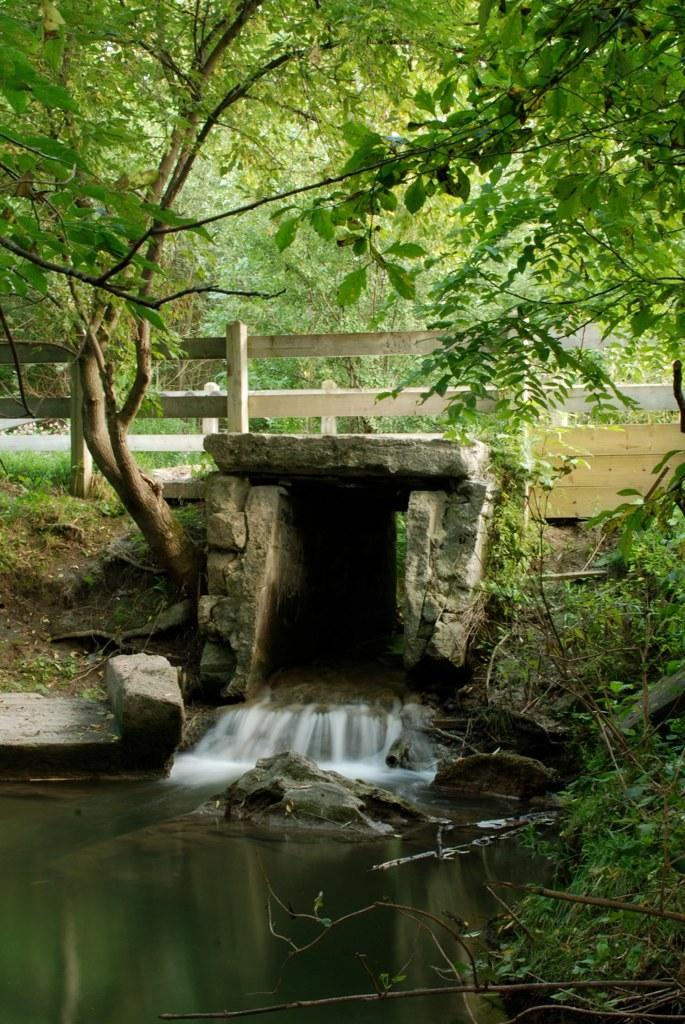What body of water is present at the bottom of the image? There is a lake at the bottom of the image. What structure can be seen crossing the lake? There is a bridge in the center of the image. What type of vegetation is visible in the image? There are plants and grass visible in the image. What can be seen in the background of the image? There are trees in the background of the image. How many fangs can be seen on the plants in the image? There are no fangs present on the plants in the image. What type of legs can be seen supporting the bridge in the image? The bridge in the image does not have legs; it is supported by its structure. 